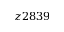Convert formula to latex. <formula><loc_0><loc_0><loc_500><loc_500>z 2 8 3 9</formula> 